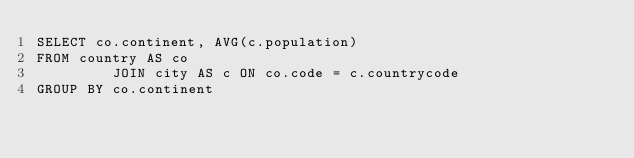<code> <loc_0><loc_0><loc_500><loc_500><_SQL_>SELECT co.continent, AVG(c.population)
FROM country AS co
         JOIN city AS c ON co.code = c.countrycode
GROUP BY co.continent</code> 